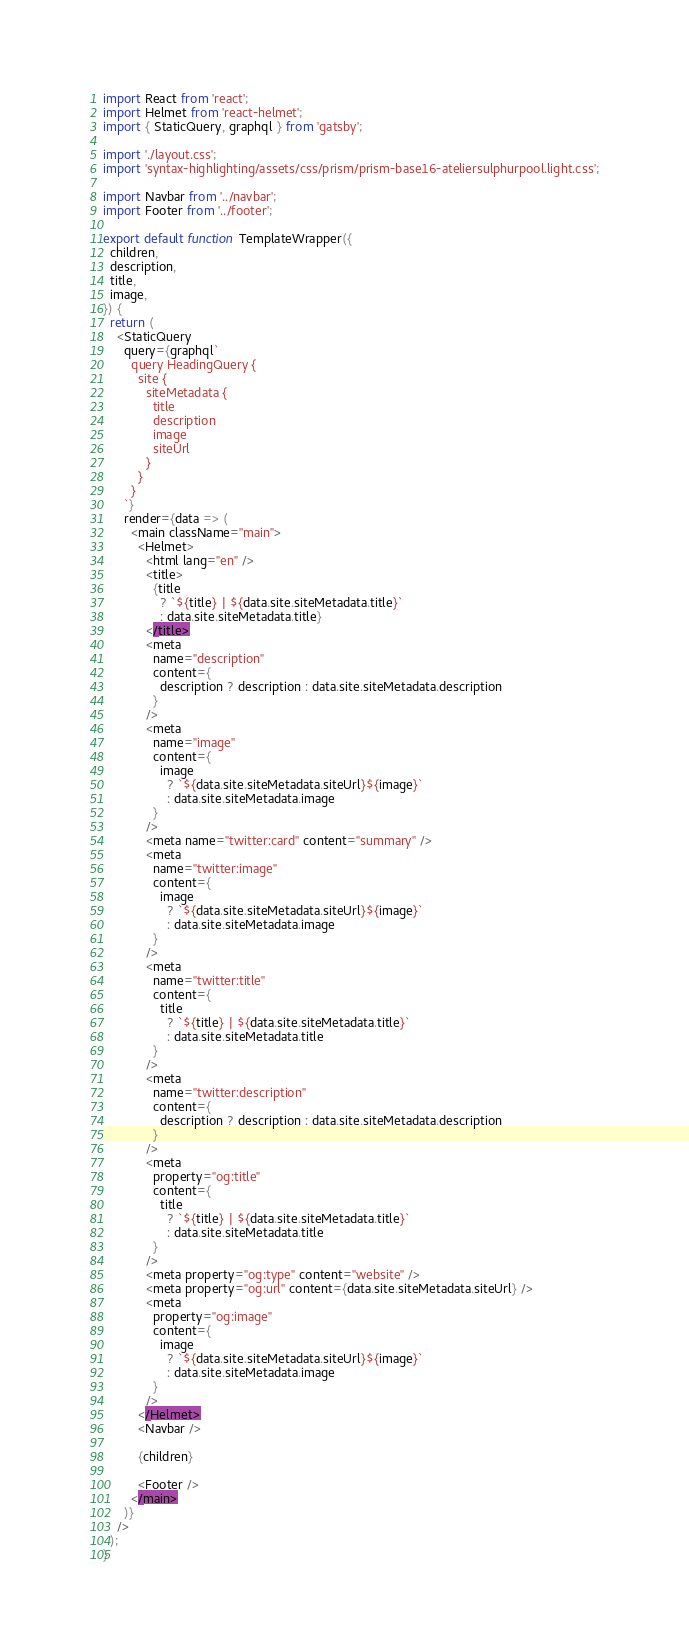Convert code to text. <code><loc_0><loc_0><loc_500><loc_500><_JavaScript_>import React from 'react';
import Helmet from 'react-helmet';
import { StaticQuery, graphql } from 'gatsby';

import './layout.css';
import 'syntax-highlighting/assets/css/prism/prism-base16-ateliersulphurpool.light.css';

import Navbar from '../navbar';
import Footer from '../footer';

export default function TemplateWrapper({
  children,
  description,
  title,
  image,
}) {
  return (
    <StaticQuery
      query={graphql`
        query HeadingQuery {
          site {
            siteMetadata {
              title
              description
              image
              siteUrl
            }
          }
        }
      `}
      render={data => (
        <main className="main">
          <Helmet>
            <html lang="en" />
            <title>
              {title
                ? `${title} | ${data.site.siteMetadata.title}`
                : data.site.siteMetadata.title}
            </title>
            <meta
              name="description"
              content={
                description ? description : data.site.siteMetadata.description
              }
            />
            <meta
              name="image"
              content={
                image
                  ? `${data.site.siteMetadata.siteUrl}${image}`
                  : data.site.siteMetadata.image
              }
            />
            <meta name="twitter:card" content="summary" />
            <meta
              name="twitter:image"
              content={
                image
                  ? `${data.site.siteMetadata.siteUrl}${image}`
                  : data.site.siteMetadata.image
              }
            />
            <meta
              name="twitter:title"
              content={
                title
                  ? `${title} | ${data.site.siteMetadata.title}`
                  : data.site.siteMetadata.title
              }
            />
            <meta
              name="twitter:description"
              content={
                description ? description : data.site.siteMetadata.description
              }
            />
            <meta
              property="og:title"
              content={
                title
                  ? `${title} | ${data.site.siteMetadata.title}`
                  : data.site.siteMetadata.title
              }
            />
            <meta property="og:type" content="website" />
            <meta property="og:url" content={data.site.siteMetadata.siteUrl} />
            <meta
              property="og:image"
              content={
                image
                  ? `${data.site.siteMetadata.siteUrl}${image}`
                  : data.site.siteMetadata.image
              }
            />
          </Helmet>
          <Navbar />

          {children}

          <Footer />
        </main>
      )}
    />
  );
}
</code> 